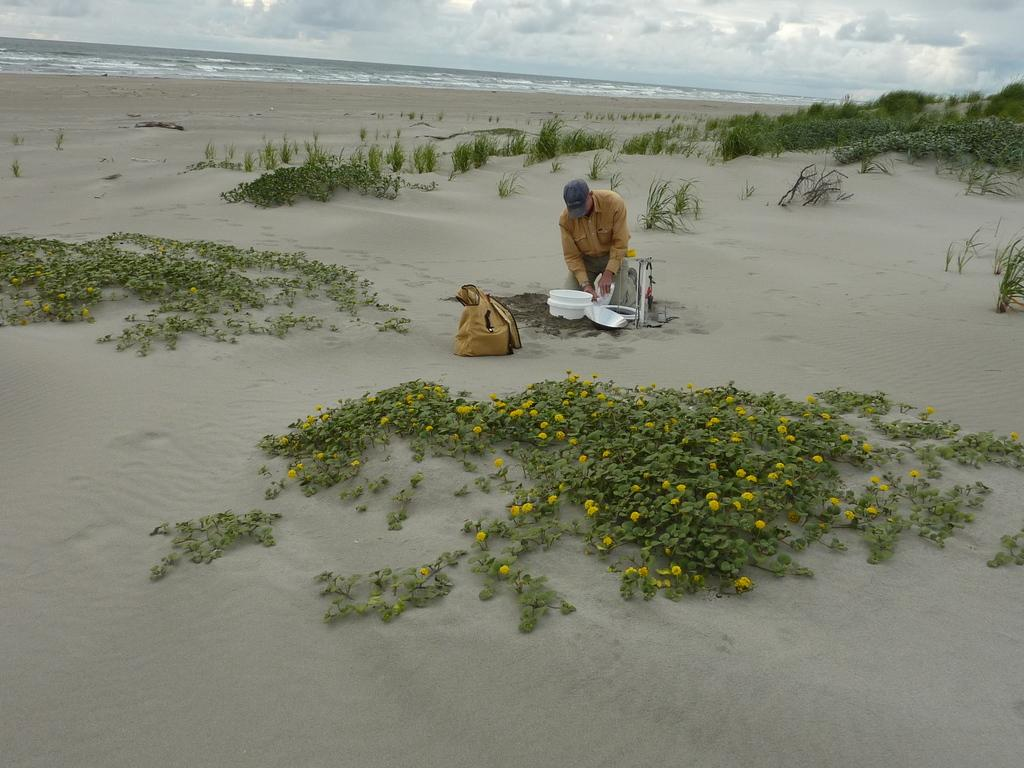What is the person in the image doing? The person is sitting on the sand in the image. What object is the person holding? The person is holding a bucket. Can you describe another object in the image? There is a plate in the image. What type of vegetation can be seen in the image? There are plants with flowers in the image. What natural element is visible in the image? There is water visible in the image. How would you describe the weather in the image? The sky is cloudy in the image. How many ants can be seen carrying the plate in the image? There are no ants present in the image, and the plate is not being carried by any ants. What is the person in the image trying to stop with the bucket? There is no indication in the image that the person is trying to stop anything with the bucket. 